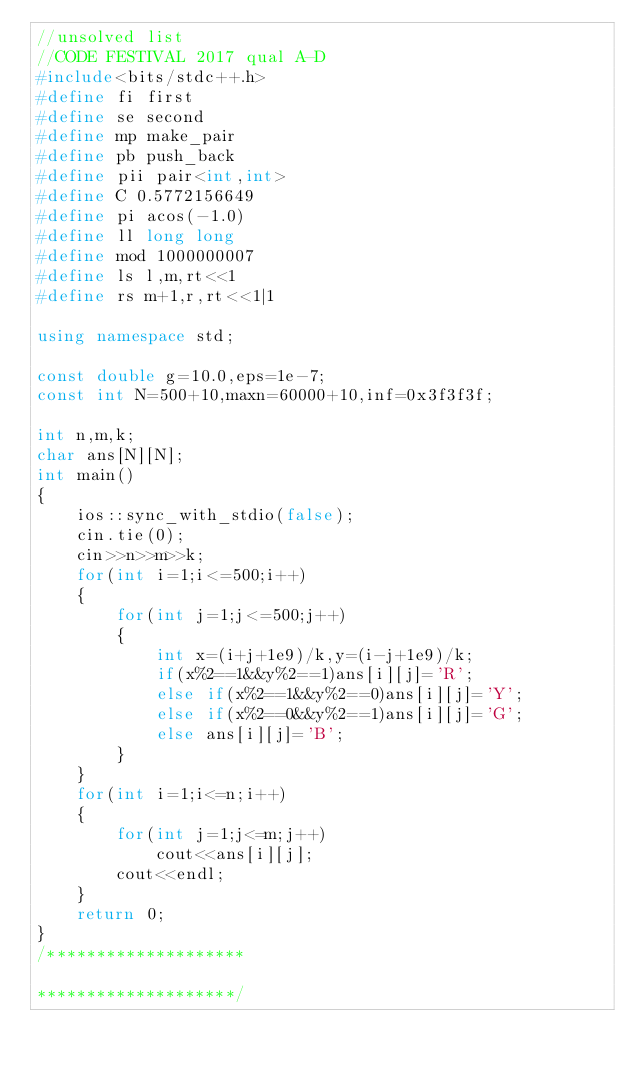Convert code to text. <code><loc_0><loc_0><loc_500><loc_500><_C++_>//unsolved list
//CODE FESTIVAL 2017 qual A-D
#include<bits/stdc++.h>
#define fi first
#define se second
#define mp make_pair
#define pb push_back
#define pii pair<int,int>
#define C 0.5772156649
#define pi acos(-1.0)
#define ll long long
#define mod 1000000007
#define ls l,m,rt<<1
#define rs m+1,r,rt<<1|1

using namespace std;

const double g=10.0,eps=1e-7;
const int N=500+10,maxn=60000+10,inf=0x3f3f3f;

int n,m,k;
char ans[N][N];
int main()
{
    ios::sync_with_stdio(false);
    cin.tie(0);
    cin>>n>>m>>k;
    for(int i=1;i<=500;i++)
    {
        for(int j=1;j<=500;j++)
        {
            int x=(i+j+1e9)/k,y=(i-j+1e9)/k;
            if(x%2==1&&y%2==1)ans[i][j]='R';
            else if(x%2==1&&y%2==0)ans[i][j]='Y';
            else if(x%2==0&&y%2==1)ans[i][j]='G';
            else ans[i][j]='B';
        }
    }
    for(int i=1;i<=n;i++)
    {
        for(int j=1;j<=m;j++)
            cout<<ans[i][j];
        cout<<endl;
    }
    return 0;
}
/********************

********************/
</code> 